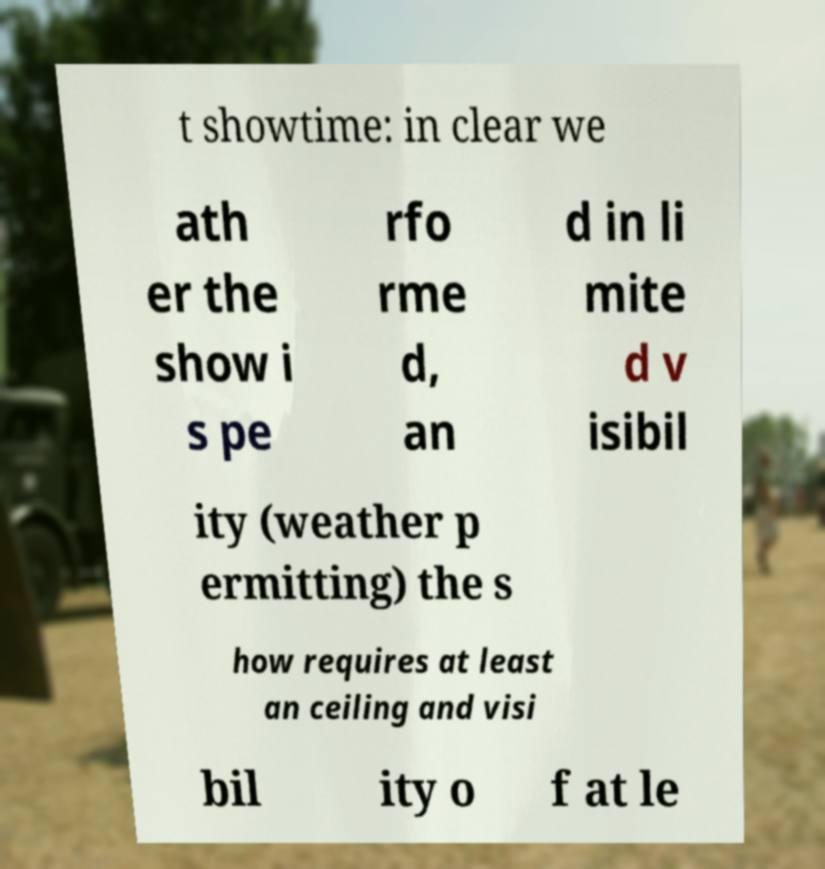For documentation purposes, I need the text within this image transcribed. Could you provide that? t showtime: in clear we ath er the show i s pe rfo rme d, an d in li mite d v isibil ity (weather p ermitting) the s how requires at least an ceiling and visi bil ity o f at le 